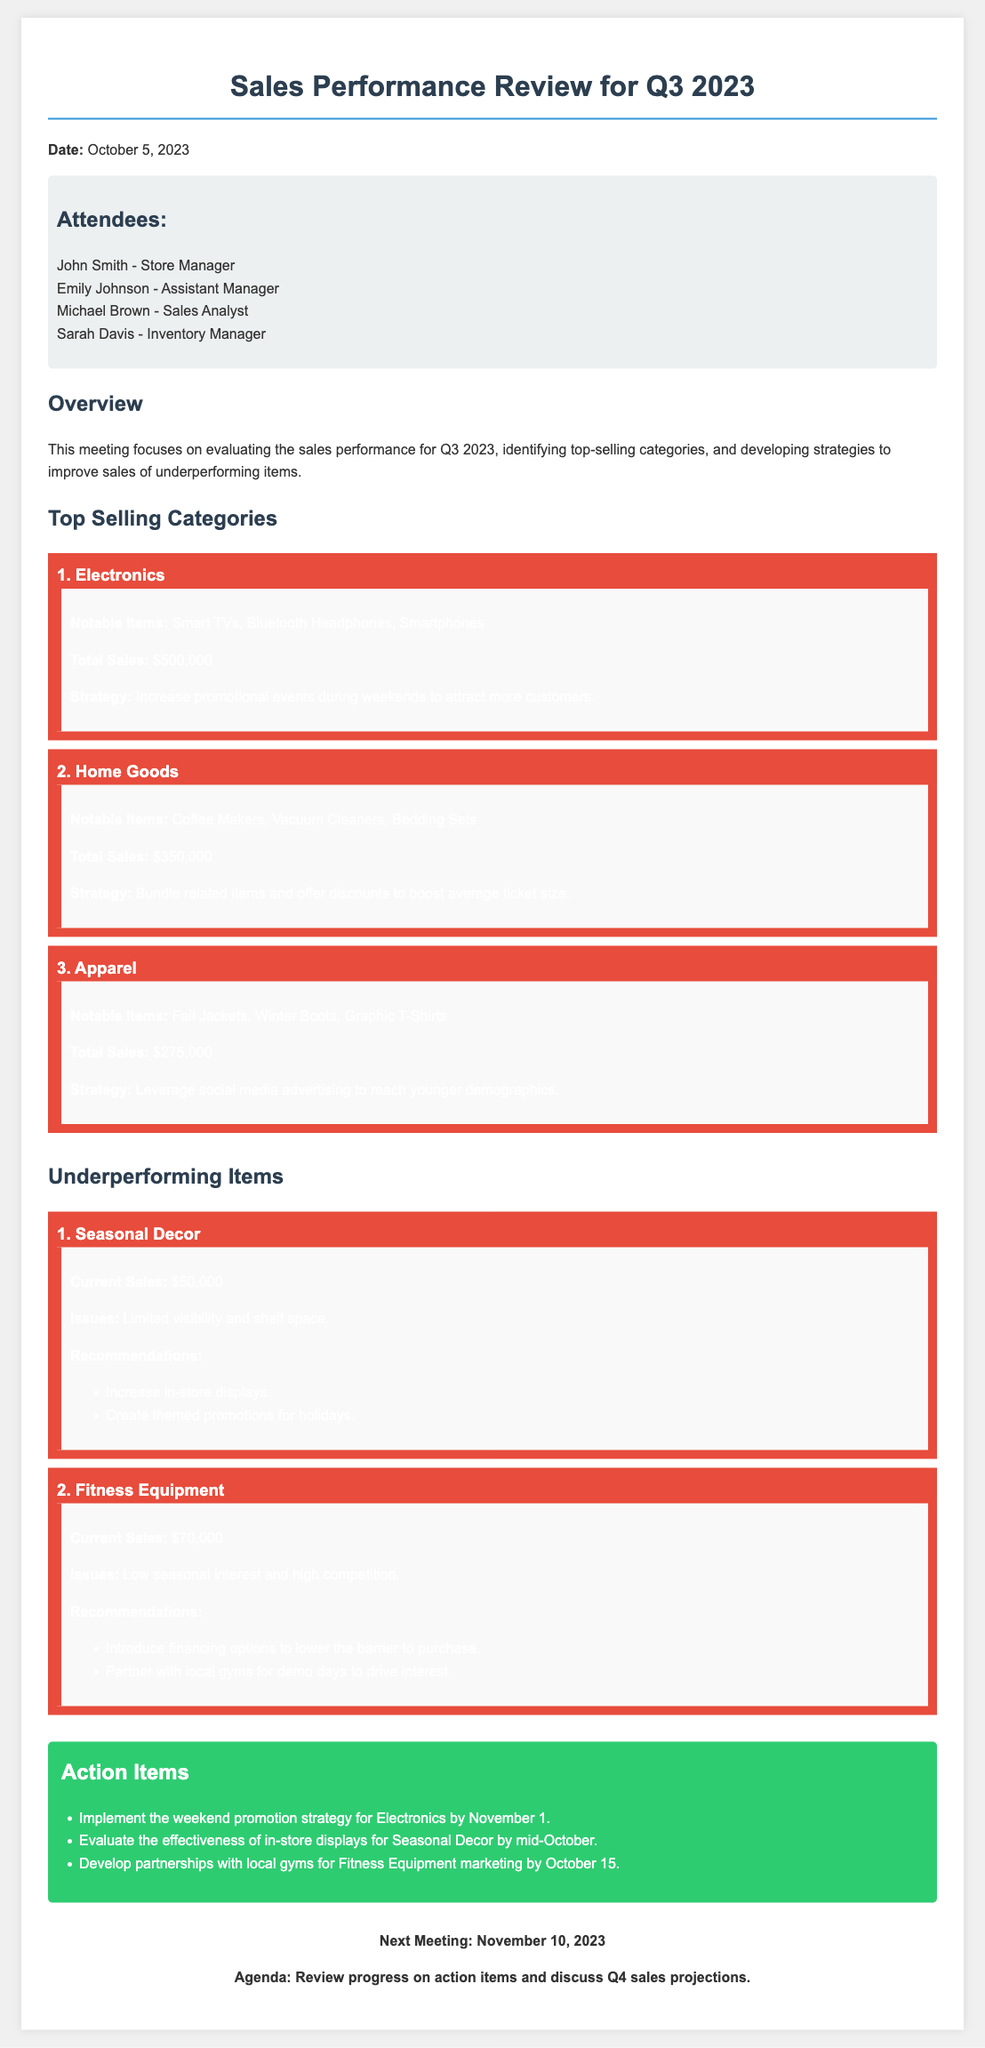What is the date of the meeting? The date of the meeting is stated at the beginning of the document, which is October 5, 2023.
Answer: October 5, 2023 Who is the store manager? The store manager is listed in the attendees section, which identifies John Smith as the store manager.
Answer: John Smith What are the notable items of the top-selling category in Electronics? The notable items are specified in the top-selling categories section under Electronics, which includes Smart TVs, Bluetooth Headphones, and Smartphones.
Answer: Smart TVs, Bluetooth Headphones, Smartphones What is the total sales revenue for Home Goods? The total sales revenue for Home Goods is provided in the details, which is $350,000.
Answer: $350,000 What issue is mentioned for Seasonal Decor? The issue for Seasonal Decor is listed in the underperforming items section, stating "Limited visibility and shelf space."
Answer: Limited visibility and shelf space Which strategy is recommended for Fitness Equipment? One of the recommendations for Fitness Equipment involves introducing financing options, which is specified in the document under recommendations.
Answer: Introduce financing options What is the next meeting date? The next meeting date is explicitly mentioned at the end of the document, which is November 10, 2023.
Answer: November 10, 2023 How much revenue does Apparel generate? The revenue for Apparel is indicated in the top-selling categories section as $275,000.
Answer: $275,000 What is the strategy for increasing sales of Seasonal Decor? The strategy for Seasonal Decor includes creating themed promotions, detailed in the recommendations section.
Answer: Create themed promotions 